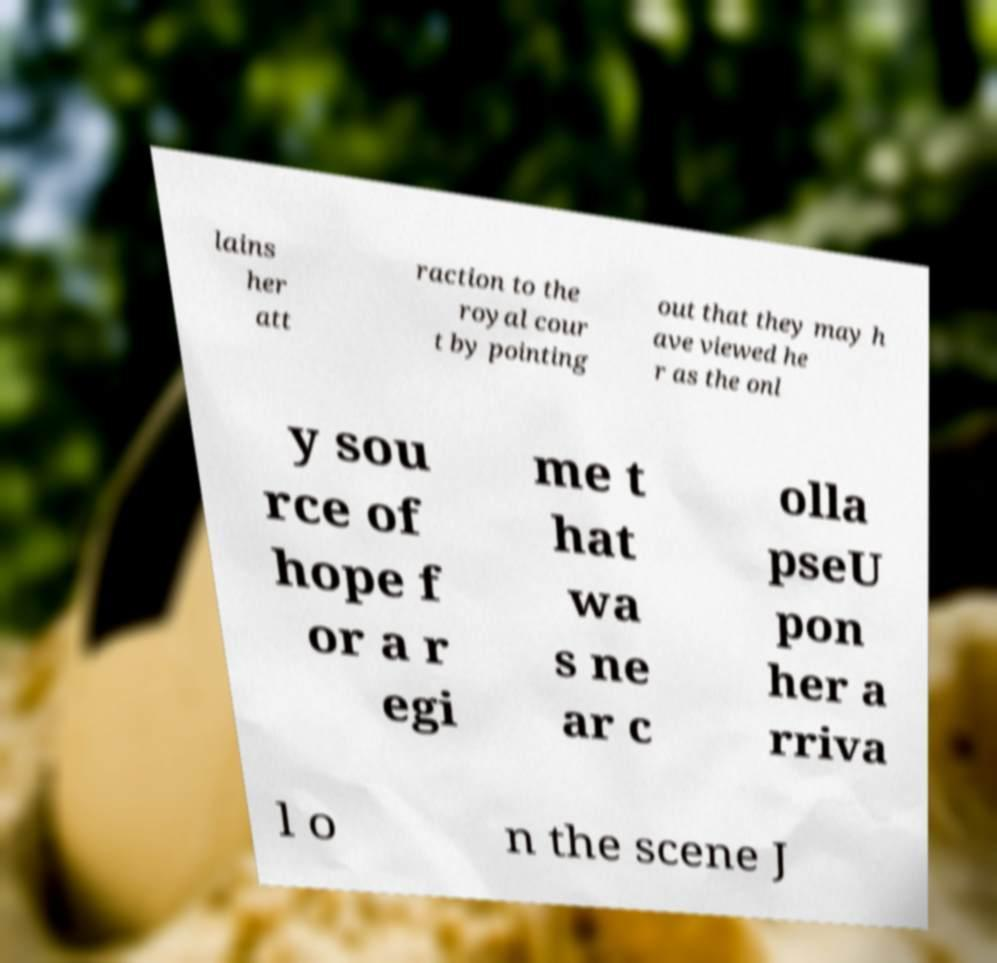There's text embedded in this image that I need extracted. Can you transcribe it verbatim? lains her att raction to the royal cour t by pointing out that they may h ave viewed he r as the onl y sou rce of hope f or a r egi me t hat wa s ne ar c olla pseU pon her a rriva l o n the scene J 